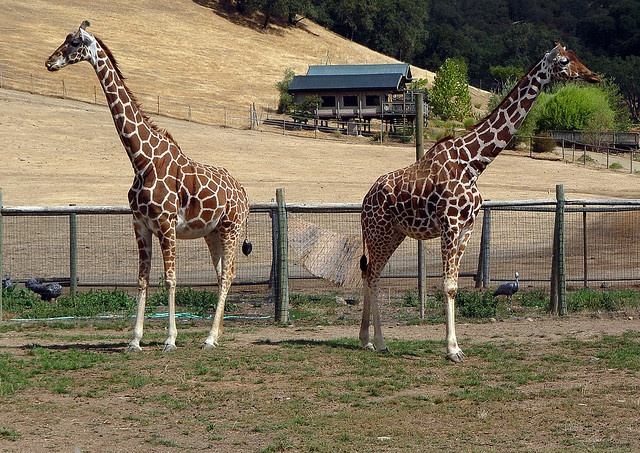Describe the objects in this image and their specific colors. I can see giraffe in tan, maroon, black, and gray tones, giraffe in tan, black, maroon, gray, and darkgray tones, bird in tan, black, and gray tones, bird in tan, black, navy, gray, and darkgray tones, and bird in tan, gray, black, and darkgreen tones in this image. 